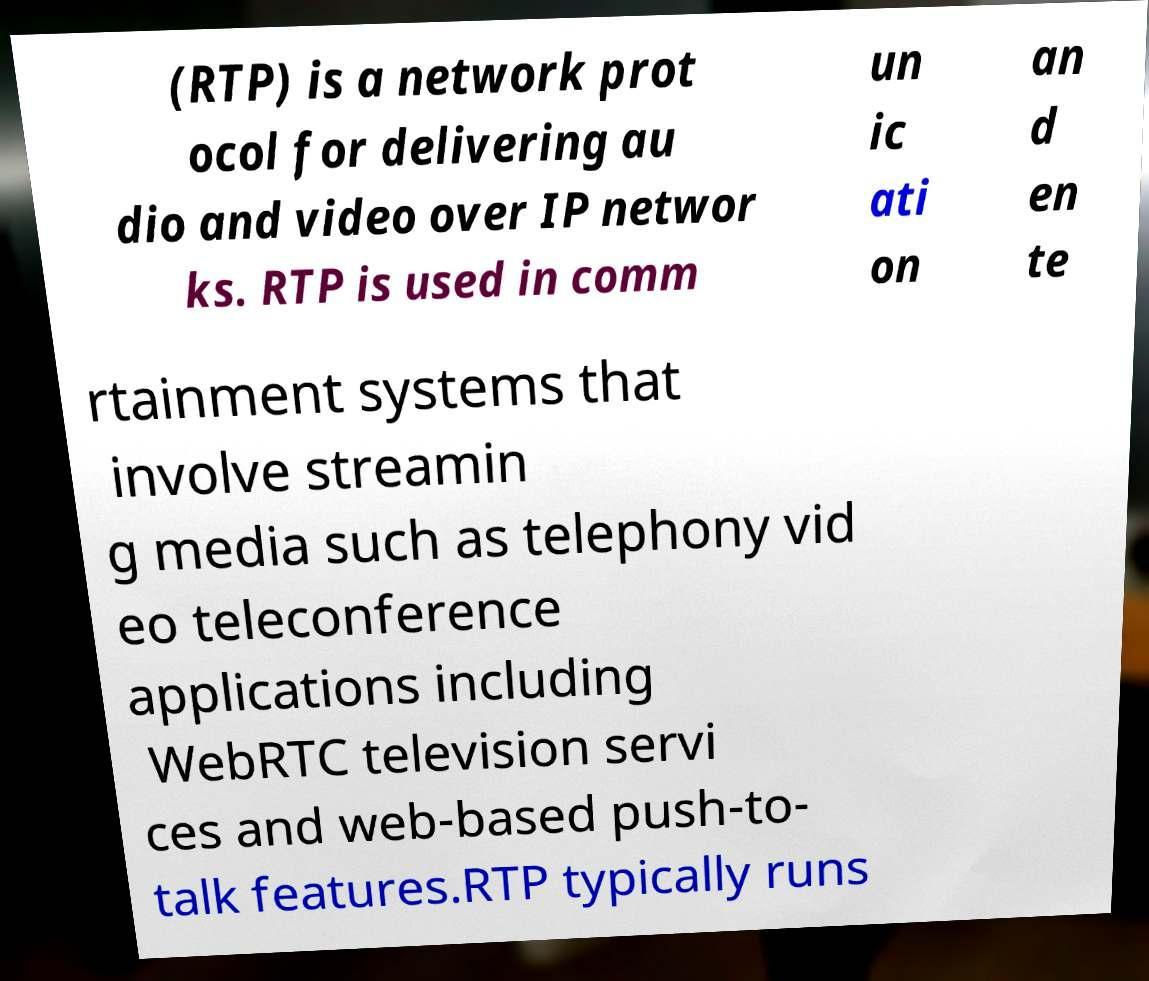There's text embedded in this image that I need extracted. Can you transcribe it verbatim? (RTP) is a network prot ocol for delivering au dio and video over IP networ ks. RTP is used in comm un ic ati on an d en te rtainment systems that involve streamin g media such as telephony vid eo teleconference applications including WebRTC television servi ces and web-based push-to- talk features.RTP typically runs 